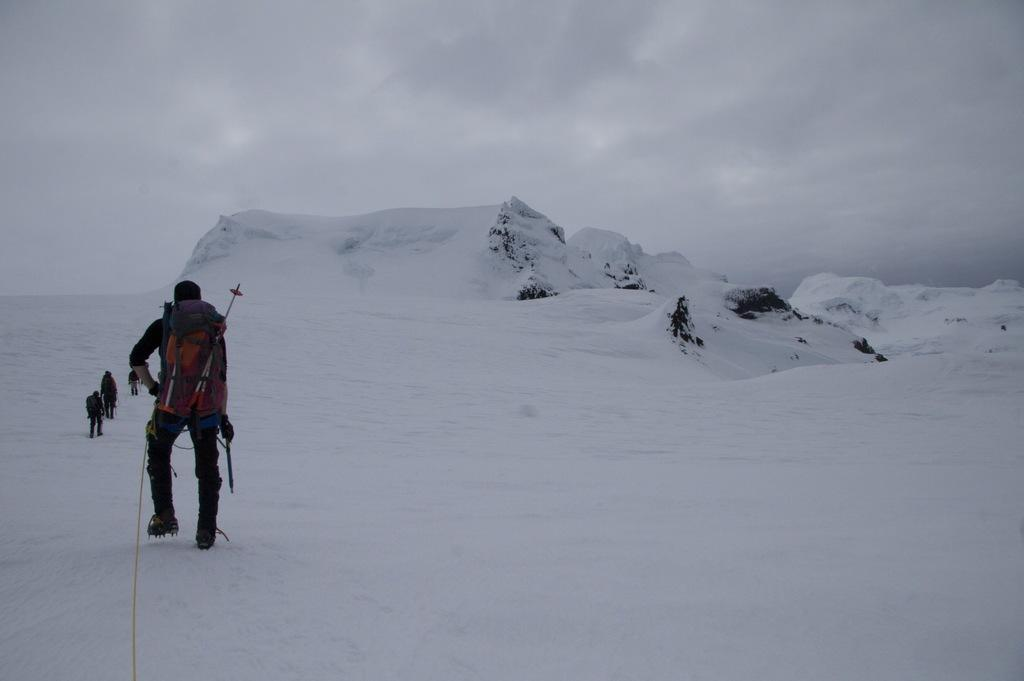What is happening in the image involving a group of people? There is a group of people in the image, and they are walking on the snow. What can be seen in the background of the image? There are clouds visible in the background of the image. What type of ball is being used by the group of people in the image? There is no ball present in the image; the group of people is walking on the snow. 